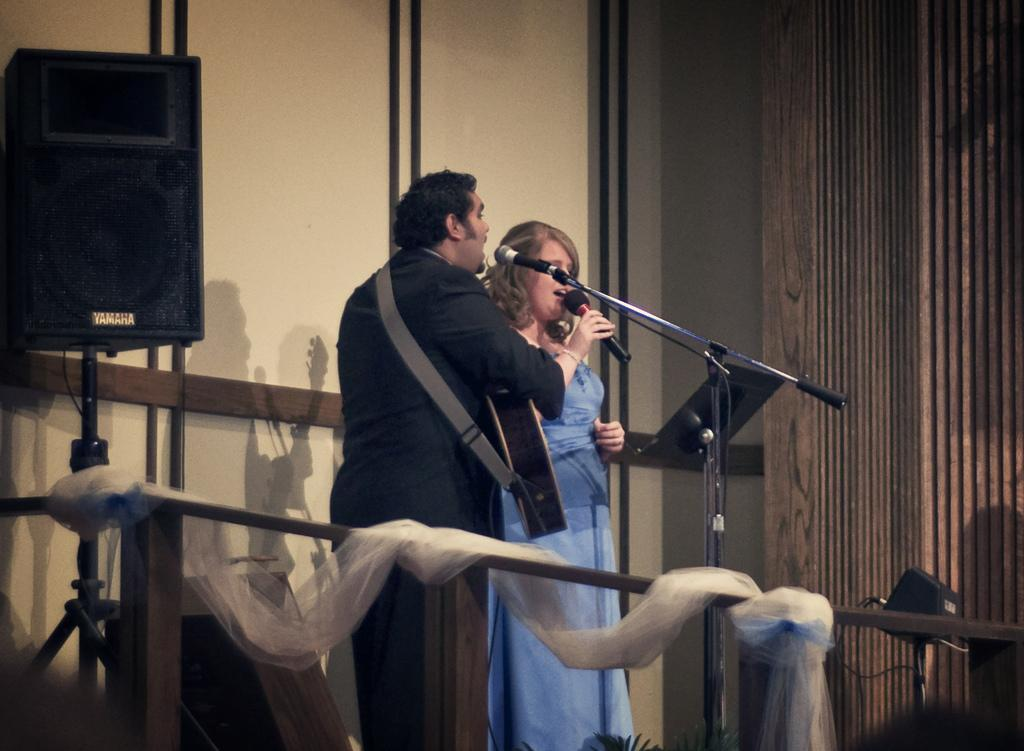How many people are present in the image? There are two people in the image, a man and a woman. What are the man and the woman doing in the image? Both the man and the woman are singing in the image. What object is present for amplifying their voices? There is a microphone in the image. What is the device used for playing the sound? There is a sound box with a stand in the image. What instrument is the man wearing? The man is wearing a guitar. Where is the rabbit sitting while listening to the music in the image? There is no rabbit present in the image. What type of fiction is being performed by the man and the woman in the image? The image does not depict a fictional performance; it shows the man and the woman singing. 